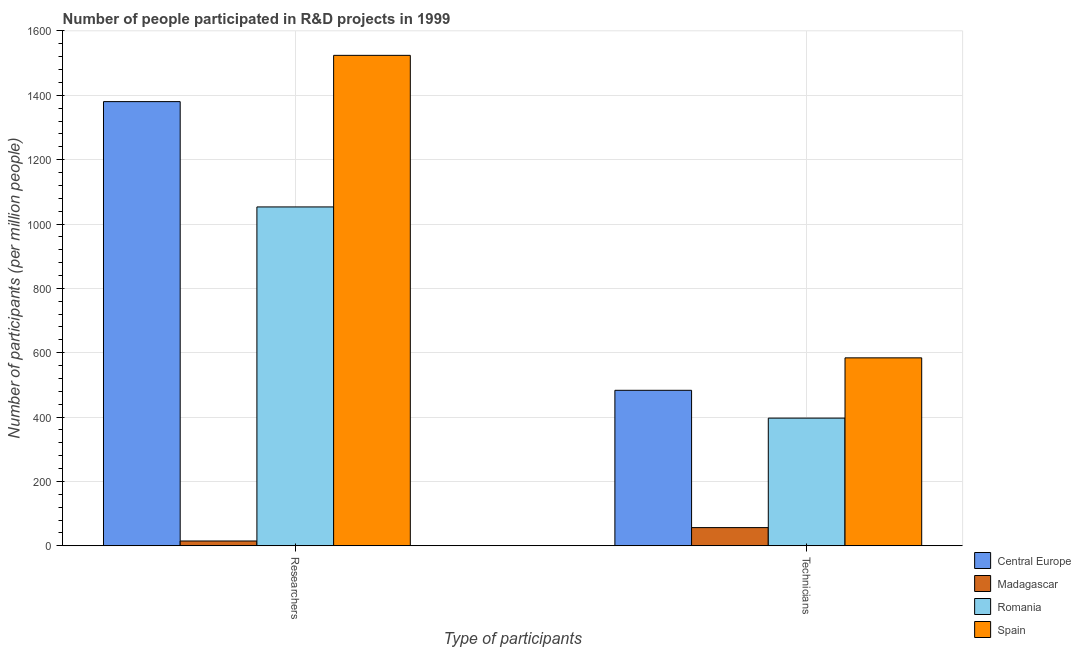How many different coloured bars are there?
Provide a short and direct response. 4. Are the number of bars per tick equal to the number of legend labels?
Provide a short and direct response. Yes. How many bars are there on the 2nd tick from the right?
Your answer should be very brief. 4. What is the label of the 1st group of bars from the left?
Provide a short and direct response. Researchers. What is the number of researchers in Romania?
Your answer should be very brief. 1053.14. Across all countries, what is the maximum number of researchers?
Keep it short and to the point. 1524.24. Across all countries, what is the minimum number of researchers?
Keep it short and to the point. 14.87. In which country was the number of researchers minimum?
Give a very brief answer. Madagascar. What is the total number of technicians in the graph?
Provide a succinct answer. 1520.53. What is the difference between the number of technicians in Madagascar and that in Central Europe?
Make the answer very short. -426.73. What is the difference between the number of researchers in Madagascar and the number of technicians in Central Europe?
Offer a terse response. -468.33. What is the average number of technicians per country?
Give a very brief answer. 380.13. What is the difference between the number of researchers and number of technicians in Madagascar?
Offer a terse response. -41.6. In how many countries, is the number of researchers greater than 880 ?
Provide a succinct answer. 3. What is the ratio of the number of researchers in Romania to that in Spain?
Offer a terse response. 0.69. Is the number of technicians in Central Europe less than that in Romania?
Your answer should be compact. No. What does the 2nd bar from the left in Researchers represents?
Ensure brevity in your answer.  Madagascar. What does the 3rd bar from the right in Researchers represents?
Provide a short and direct response. Madagascar. How many bars are there?
Your answer should be very brief. 8. How many countries are there in the graph?
Your response must be concise. 4. What is the difference between two consecutive major ticks on the Y-axis?
Make the answer very short. 200. Does the graph contain any zero values?
Give a very brief answer. No. Where does the legend appear in the graph?
Your answer should be very brief. Bottom right. How many legend labels are there?
Offer a terse response. 4. How are the legend labels stacked?
Your response must be concise. Vertical. What is the title of the graph?
Your response must be concise. Number of people participated in R&D projects in 1999. What is the label or title of the X-axis?
Make the answer very short. Type of participants. What is the label or title of the Y-axis?
Ensure brevity in your answer.  Number of participants (per million people). What is the Number of participants (per million people) in Central Europe in Researchers?
Your response must be concise. 1380.45. What is the Number of participants (per million people) of Madagascar in Researchers?
Ensure brevity in your answer.  14.87. What is the Number of participants (per million people) of Romania in Researchers?
Your response must be concise. 1053.14. What is the Number of participants (per million people) of Spain in Researchers?
Offer a terse response. 1524.24. What is the Number of participants (per million people) of Central Europe in Technicians?
Your answer should be compact. 483.21. What is the Number of participants (per million people) in Madagascar in Technicians?
Make the answer very short. 56.48. What is the Number of participants (per million people) of Romania in Technicians?
Give a very brief answer. 396.75. What is the Number of participants (per million people) of Spain in Technicians?
Give a very brief answer. 584.09. Across all Type of participants, what is the maximum Number of participants (per million people) in Central Europe?
Offer a terse response. 1380.45. Across all Type of participants, what is the maximum Number of participants (per million people) of Madagascar?
Your answer should be very brief. 56.48. Across all Type of participants, what is the maximum Number of participants (per million people) of Romania?
Keep it short and to the point. 1053.14. Across all Type of participants, what is the maximum Number of participants (per million people) of Spain?
Offer a very short reply. 1524.24. Across all Type of participants, what is the minimum Number of participants (per million people) of Central Europe?
Keep it short and to the point. 483.21. Across all Type of participants, what is the minimum Number of participants (per million people) of Madagascar?
Make the answer very short. 14.87. Across all Type of participants, what is the minimum Number of participants (per million people) in Romania?
Offer a terse response. 396.75. Across all Type of participants, what is the minimum Number of participants (per million people) of Spain?
Offer a very short reply. 584.09. What is the total Number of participants (per million people) in Central Europe in the graph?
Ensure brevity in your answer.  1863.66. What is the total Number of participants (per million people) in Madagascar in the graph?
Give a very brief answer. 71.35. What is the total Number of participants (per million people) of Romania in the graph?
Your answer should be compact. 1449.89. What is the total Number of participants (per million people) of Spain in the graph?
Provide a short and direct response. 2108.33. What is the difference between the Number of participants (per million people) of Central Europe in Researchers and that in Technicians?
Your answer should be compact. 897.24. What is the difference between the Number of participants (per million people) of Madagascar in Researchers and that in Technicians?
Provide a short and direct response. -41.6. What is the difference between the Number of participants (per million people) of Romania in Researchers and that in Technicians?
Provide a succinct answer. 656.39. What is the difference between the Number of participants (per million people) in Spain in Researchers and that in Technicians?
Provide a short and direct response. 940.15. What is the difference between the Number of participants (per million people) in Central Europe in Researchers and the Number of participants (per million people) in Madagascar in Technicians?
Give a very brief answer. 1323.97. What is the difference between the Number of participants (per million people) of Central Europe in Researchers and the Number of participants (per million people) of Romania in Technicians?
Make the answer very short. 983.7. What is the difference between the Number of participants (per million people) in Central Europe in Researchers and the Number of participants (per million people) in Spain in Technicians?
Keep it short and to the point. 796.36. What is the difference between the Number of participants (per million people) in Madagascar in Researchers and the Number of participants (per million people) in Romania in Technicians?
Give a very brief answer. -381.88. What is the difference between the Number of participants (per million people) of Madagascar in Researchers and the Number of participants (per million people) of Spain in Technicians?
Offer a terse response. -569.22. What is the difference between the Number of participants (per million people) of Romania in Researchers and the Number of participants (per million people) of Spain in Technicians?
Make the answer very short. 469.05. What is the average Number of participants (per million people) of Central Europe per Type of participants?
Offer a very short reply. 931.83. What is the average Number of participants (per million people) in Madagascar per Type of participants?
Offer a very short reply. 35.67. What is the average Number of participants (per million people) of Romania per Type of participants?
Keep it short and to the point. 724.95. What is the average Number of participants (per million people) of Spain per Type of participants?
Offer a very short reply. 1054.17. What is the difference between the Number of participants (per million people) of Central Europe and Number of participants (per million people) of Madagascar in Researchers?
Make the answer very short. 1365.58. What is the difference between the Number of participants (per million people) in Central Europe and Number of participants (per million people) in Romania in Researchers?
Ensure brevity in your answer.  327.31. What is the difference between the Number of participants (per million people) of Central Europe and Number of participants (per million people) of Spain in Researchers?
Offer a terse response. -143.79. What is the difference between the Number of participants (per million people) in Madagascar and Number of participants (per million people) in Romania in Researchers?
Give a very brief answer. -1038.27. What is the difference between the Number of participants (per million people) in Madagascar and Number of participants (per million people) in Spain in Researchers?
Offer a terse response. -1509.37. What is the difference between the Number of participants (per million people) in Romania and Number of participants (per million people) in Spain in Researchers?
Offer a terse response. -471.1. What is the difference between the Number of participants (per million people) in Central Europe and Number of participants (per million people) in Madagascar in Technicians?
Provide a short and direct response. 426.73. What is the difference between the Number of participants (per million people) in Central Europe and Number of participants (per million people) in Romania in Technicians?
Keep it short and to the point. 86.46. What is the difference between the Number of participants (per million people) in Central Europe and Number of participants (per million people) in Spain in Technicians?
Offer a terse response. -100.89. What is the difference between the Number of participants (per million people) of Madagascar and Number of participants (per million people) of Romania in Technicians?
Ensure brevity in your answer.  -340.27. What is the difference between the Number of participants (per million people) of Madagascar and Number of participants (per million people) of Spain in Technicians?
Your response must be concise. -527.62. What is the difference between the Number of participants (per million people) of Romania and Number of participants (per million people) of Spain in Technicians?
Give a very brief answer. -187.34. What is the ratio of the Number of participants (per million people) of Central Europe in Researchers to that in Technicians?
Your response must be concise. 2.86. What is the ratio of the Number of participants (per million people) in Madagascar in Researchers to that in Technicians?
Keep it short and to the point. 0.26. What is the ratio of the Number of participants (per million people) of Romania in Researchers to that in Technicians?
Offer a very short reply. 2.65. What is the ratio of the Number of participants (per million people) in Spain in Researchers to that in Technicians?
Give a very brief answer. 2.61. What is the difference between the highest and the second highest Number of participants (per million people) of Central Europe?
Offer a very short reply. 897.24. What is the difference between the highest and the second highest Number of participants (per million people) of Madagascar?
Make the answer very short. 41.6. What is the difference between the highest and the second highest Number of participants (per million people) in Romania?
Provide a short and direct response. 656.39. What is the difference between the highest and the second highest Number of participants (per million people) in Spain?
Provide a succinct answer. 940.15. What is the difference between the highest and the lowest Number of participants (per million people) in Central Europe?
Your response must be concise. 897.24. What is the difference between the highest and the lowest Number of participants (per million people) of Madagascar?
Keep it short and to the point. 41.6. What is the difference between the highest and the lowest Number of participants (per million people) of Romania?
Your response must be concise. 656.39. What is the difference between the highest and the lowest Number of participants (per million people) in Spain?
Keep it short and to the point. 940.15. 